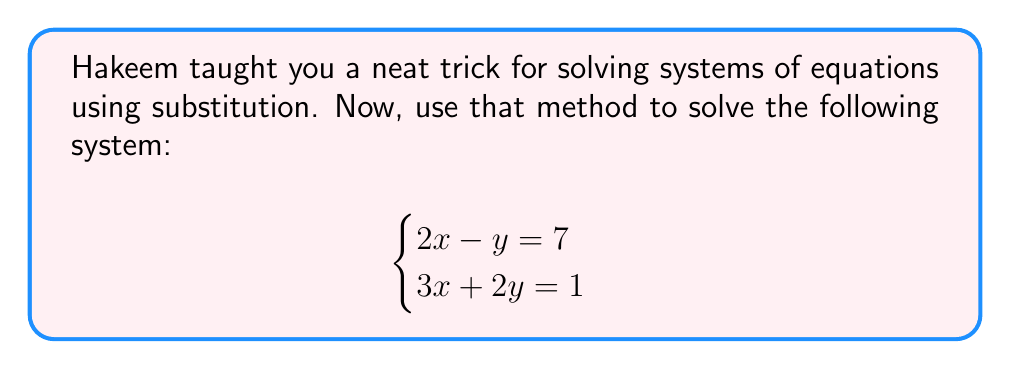Solve this math problem. Let's follow Hakeem's method step-by-step:

1) First, we'll isolate y in the first equation:
   $2x - y = 7$
   $-y = -2x + 7$
   $y = 2x - 7$

2) Now, substitute this expression for y into the second equation:
   $3x + 2y = 1$
   $3x + 2(2x - 7) = 1$

3) Simplify:
   $3x + 4x - 14 = 1$
   $7x - 14 = 1$

4) Add 14 to both sides:
   $7x = 15$

5) Divide both sides by 7:
   $x = \frac{15}{7}$

6) Now that we know x, substitute it back into the equation from step 1 to find y:
   $y = 2(\frac{15}{7}) - 7$
   $y = \frac{30}{7} - 7$
   $y = \frac{30}{7} - \frac{49}{7}$
   $y = -\frac{19}{7}$

Therefore, the solution is $x = \frac{15}{7}$ and $y = -\frac{19}{7}$.
Answer: $(\frac{15}{7}, -\frac{19}{7})$ 